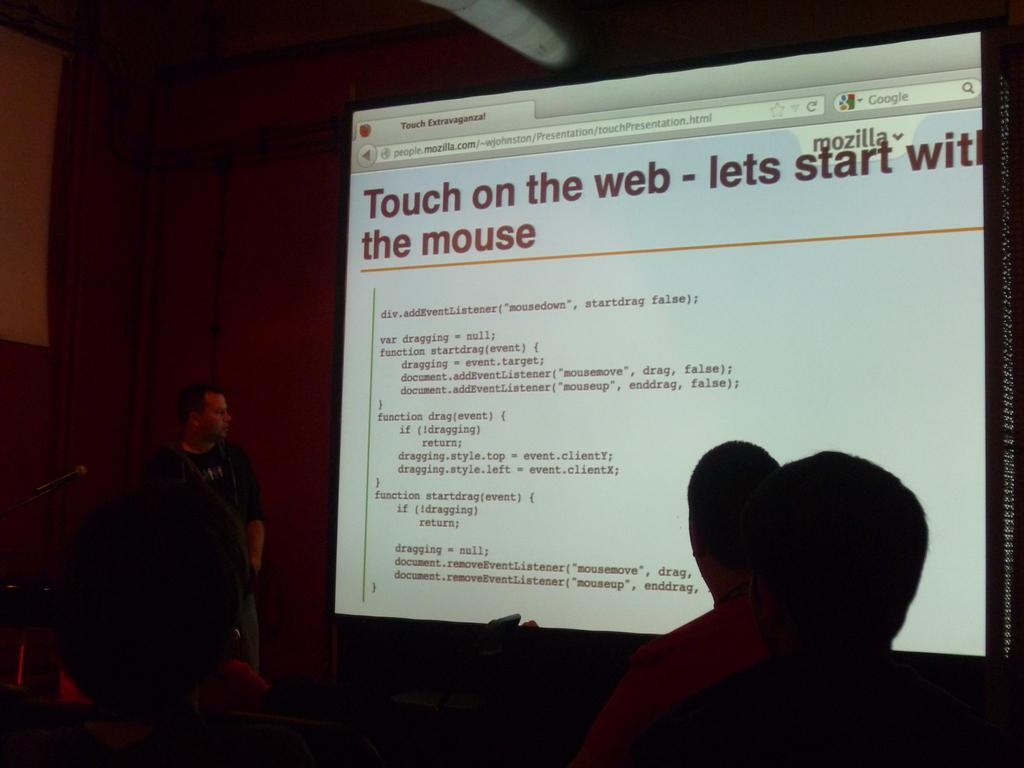What is the main object in the center of the image? There is a screen in the center of the image. What can be seen on the screen? Text is visible on the screen. Where are the persons located in the image? There are persons on the right side of the image and on the left side of the image. What is visible in the background of the image? There is a wall in the background of the image. How does the balance of the persons on the right side of the image compare to the persons on the left side of the image? There is no information about the balance or comparison of the persons on either side of the image, as the provided facts do not mention any weights or measurements. 